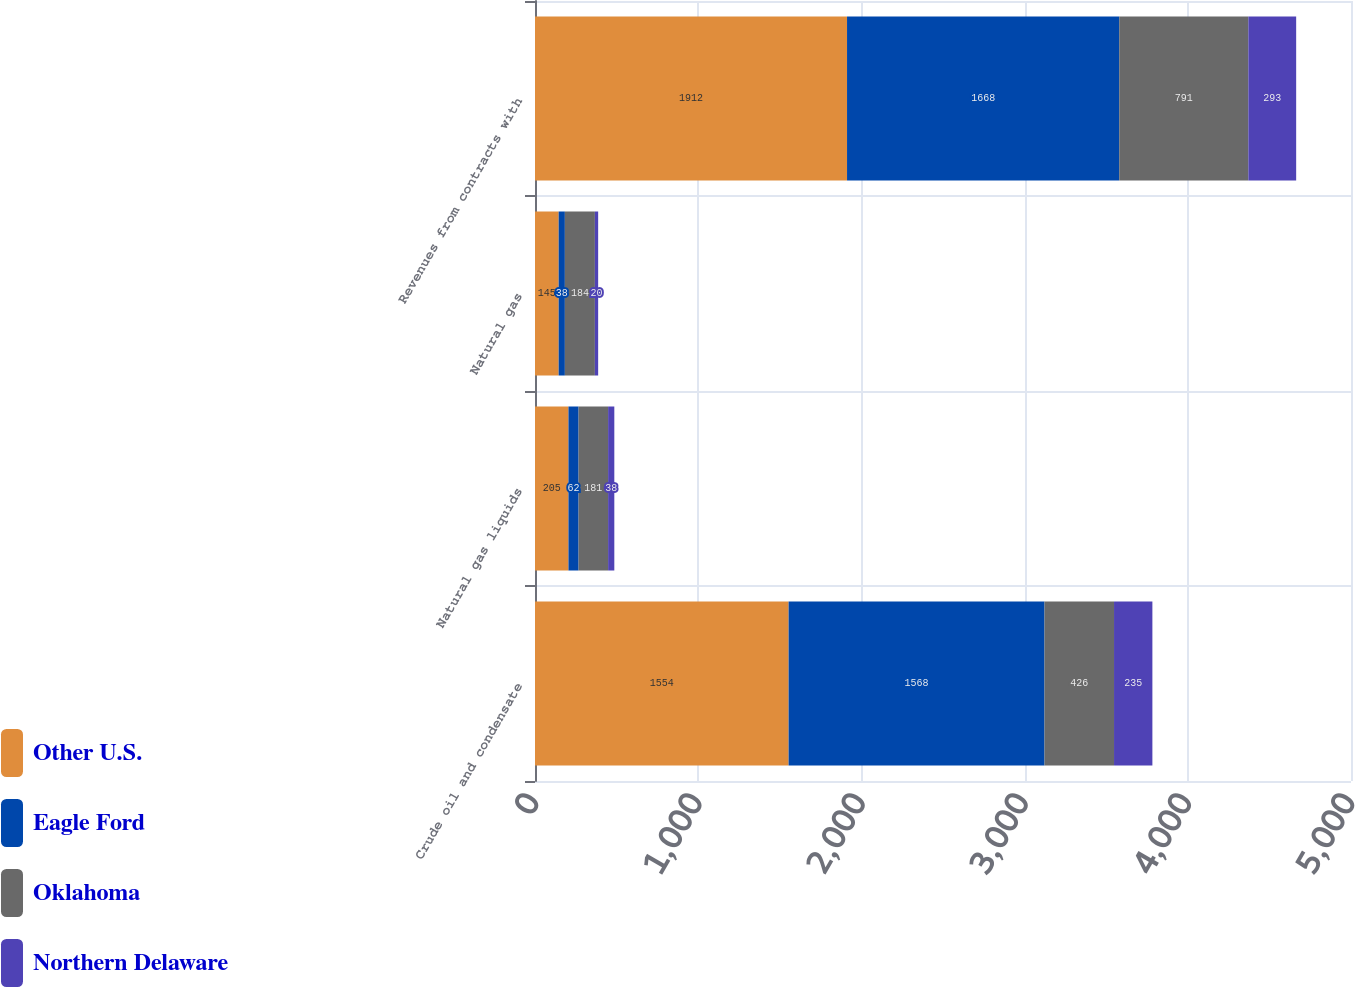<chart> <loc_0><loc_0><loc_500><loc_500><stacked_bar_chart><ecel><fcel>Crude oil and condensate<fcel>Natural gas liquids<fcel>Natural gas<fcel>Revenues from contracts with<nl><fcel>Other U.S.<fcel>1554<fcel>205<fcel>145<fcel>1912<nl><fcel>Eagle Ford<fcel>1568<fcel>62<fcel>38<fcel>1668<nl><fcel>Oklahoma<fcel>426<fcel>181<fcel>184<fcel>791<nl><fcel>Northern Delaware<fcel>235<fcel>38<fcel>20<fcel>293<nl></chart> 